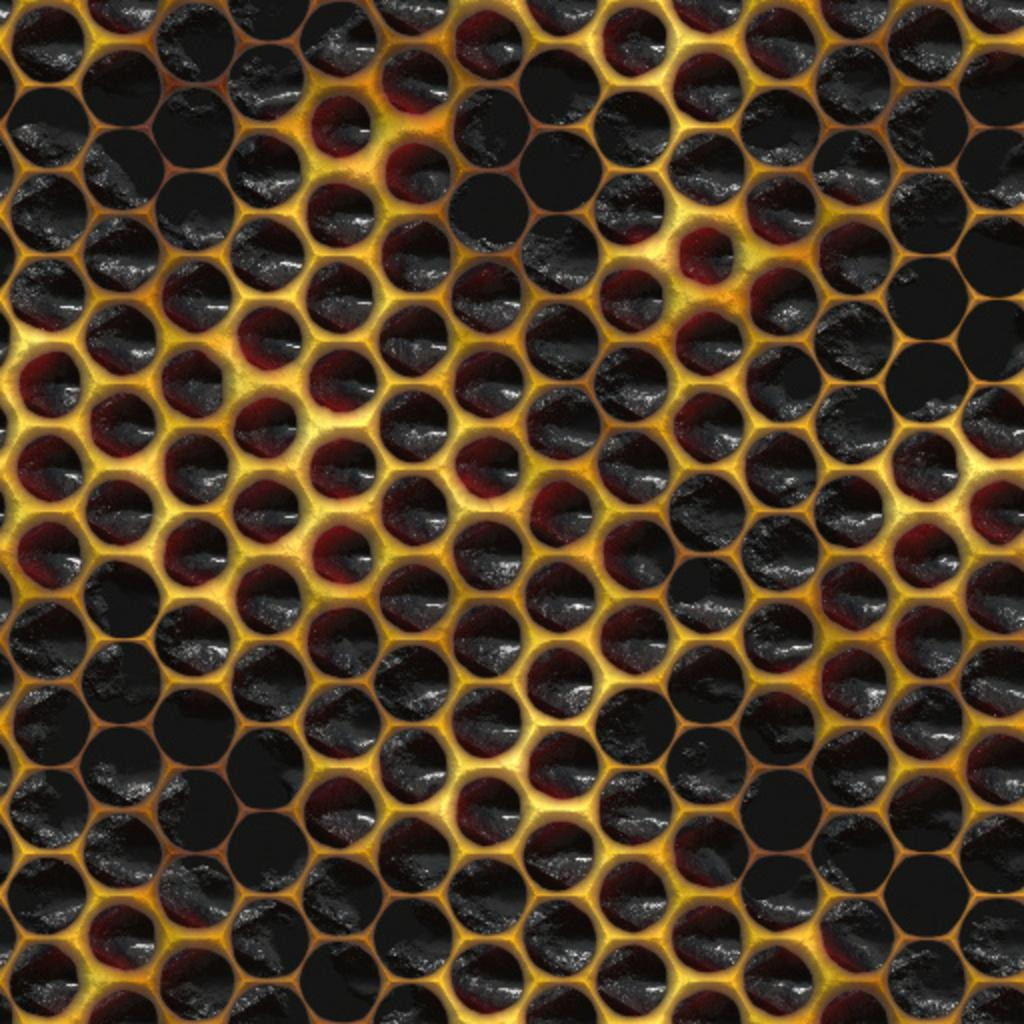What is the main subject of the image? The main subject of the image is a honeycomb. What type of fruit can be seen hanging from the honeycomb in the image? There is no fruit present in the image, as it only features a honeycomb. 